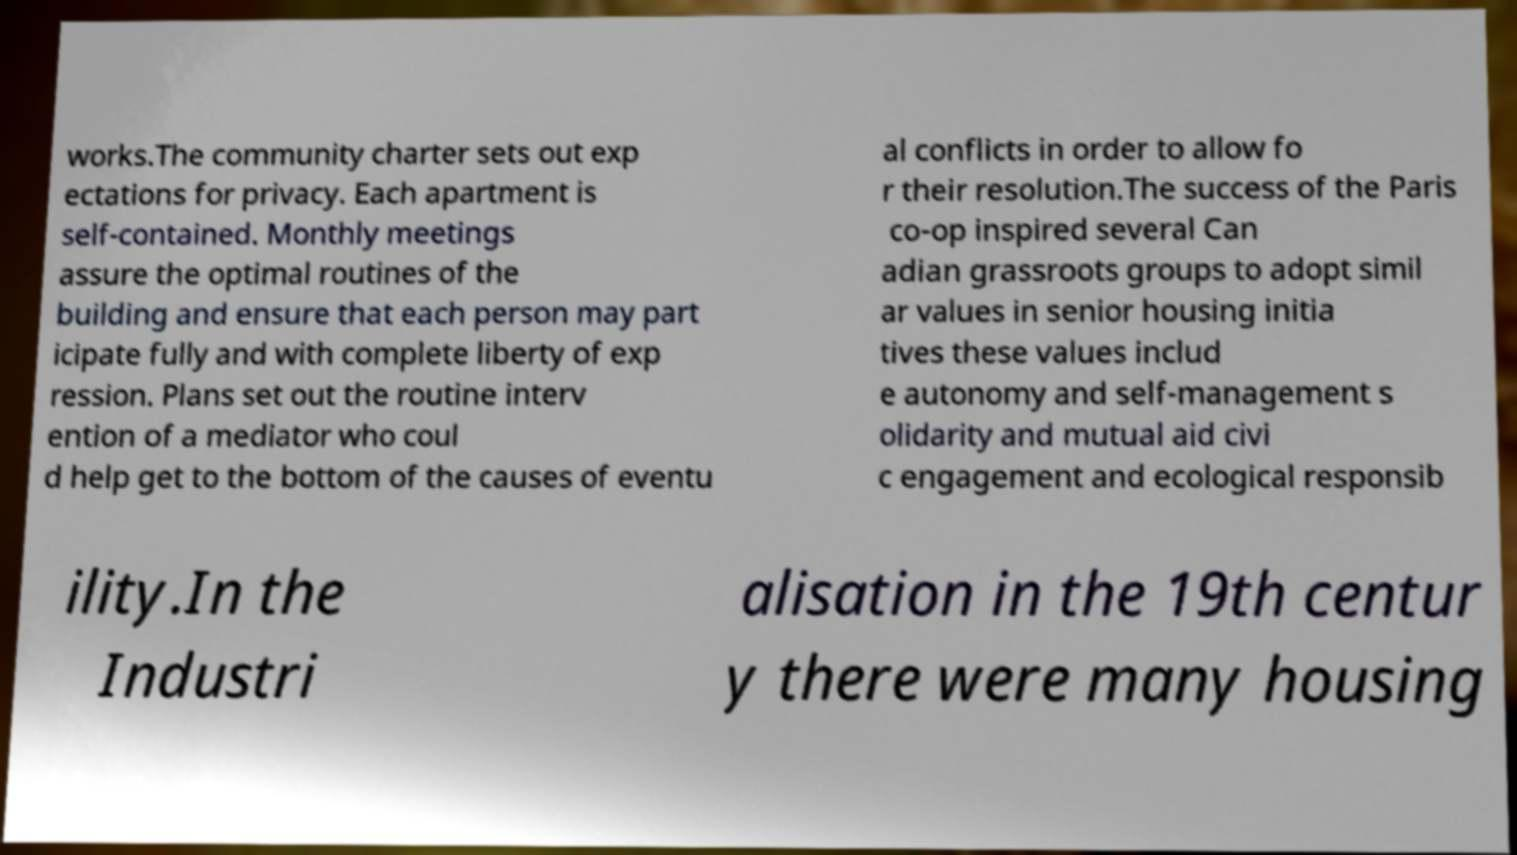Can you read and provide the text displayed in the image?This photo seems to have some interesting text. Can you extract and type it out for me? works.The community charter sets out exp ectations for privacy. Each apartment is self-contained. Monthly meetings assure the optimal routines of the building and ensure that each person may part icipate fully and with complete liberty of exp ression. Plans set out the routine interv ention of a mediator who coul d help get to the bottom of the causes of eventu al conflicts in order to allow fo r their resolution.The success of the Paris co-op inspired several Can adian grassroots groups to adopt simil ar values in senior housing initia tives these values includ e autonomy and self-management s olidarity and mutual aid civi c engagement and ecological responsib ility.In the Industri alisation in the 19th centur y there were many housing 